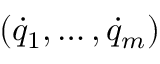Convert formula to latex. <formula><loc_0><loc_0><loc_500><loc_500>( { \dot { q } } _ { 1 } , \dots , { \dot { q } } _ { m } )</formula> 